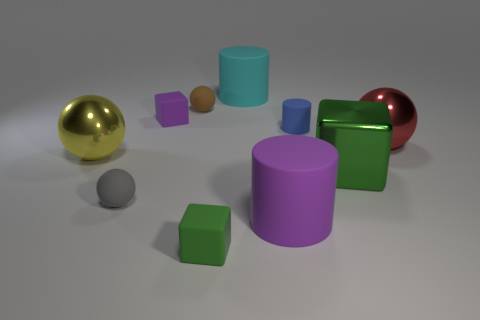There is a small cube that is the same color as the big block; what material is it?
Your answer should be very brief. Rubber. What shape is the red metallic object that is the same size as the green shiny object?
Your answer should be very brief. Sphere. Is the color of the rubber cylinder that is in front of the yellow shiny object the same as the large metallic cube?
Make the answer very short. No. What number of things are big metal objects that are to the left of the small gray object or tiny purple rubber objects?
Provide a short and direct response. 2. Are there more brown matte things that are behind the big green metal block than large green metal objects that are in front of the gray object?
Your answer should be very brief. Yes. Is the brown thing made of the same material as the big cyan thing?
Give a very brief answer. Yes. What is the shape of the object that is in front of the yellow ball and on the right side of the tiny blue cylinder?
Give a very brief answer. Cube. What is the shape of the yellow object that is made of the same material as the large green block?
Offer a very short reply. Sphere. Are any big cylinders visible?
Make the answer very short. Yes. There is a small matte cube behind the tiny blue rubber thing; are there any rubber balls on the right side of it?
Your answer should be very brief. Yes. 